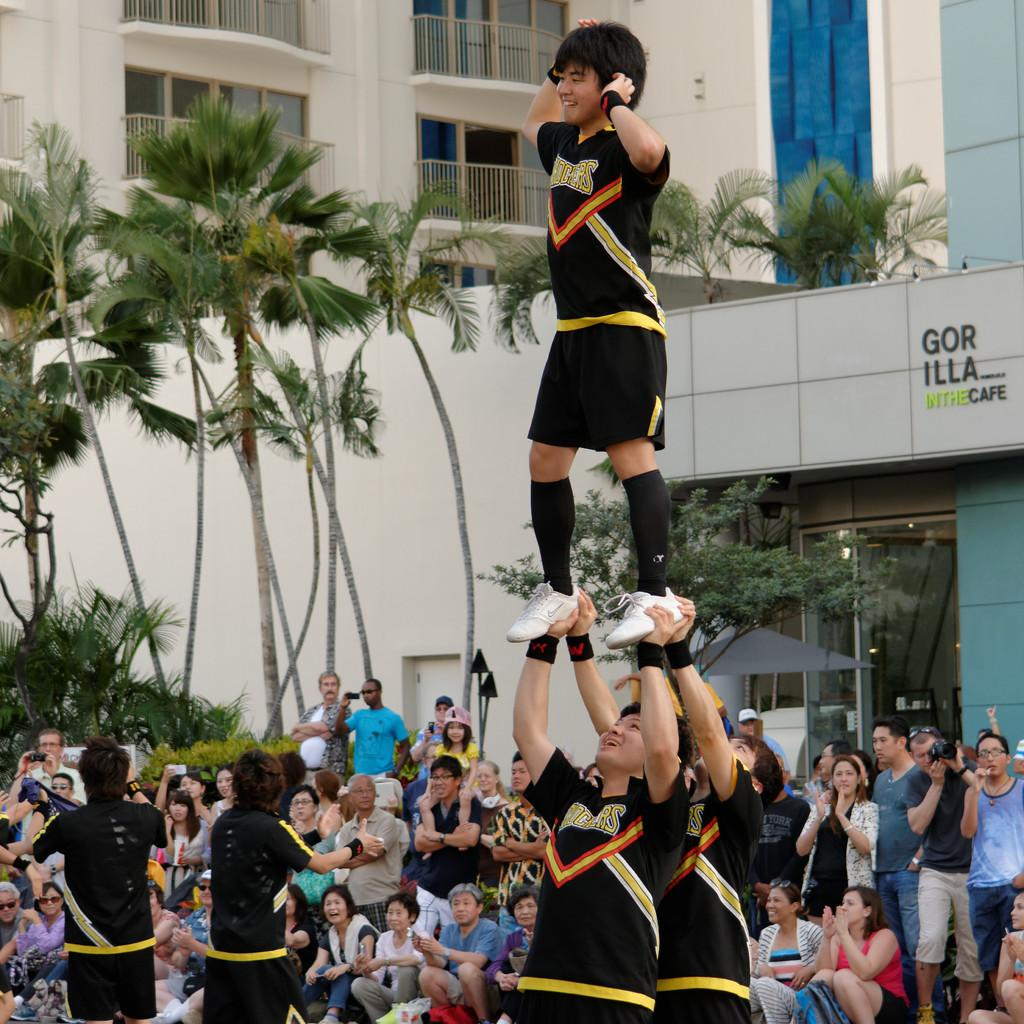<image>
Share a concise interpretation of the image provided. Male cheerleaders cheer on the crowd in front of a store called Gor Illa In The Cafe 